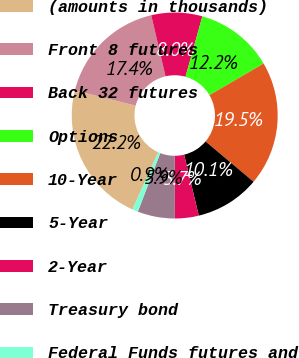Convert chart. <chart><loc_0><loc_0><loc_500><loc_500><pie_chart><fcel>(amounts in thousands)<fcel>Front 8 futures<fcel>Back 32 futures<fcel>Options<fcel>10-Year<fcel>5-Year<fcel>2-Year<fcel>Treasury bond<fcel>Federal Funds futures and<nl><fcel>22.21%<fcel>17.41%<fcel>7.99%<fcel>12.25%<fcel>19.55%<fcel>10.12%<fcel>3.73%<fcel>5.86%<fcel>0.89%<nl></chart> 